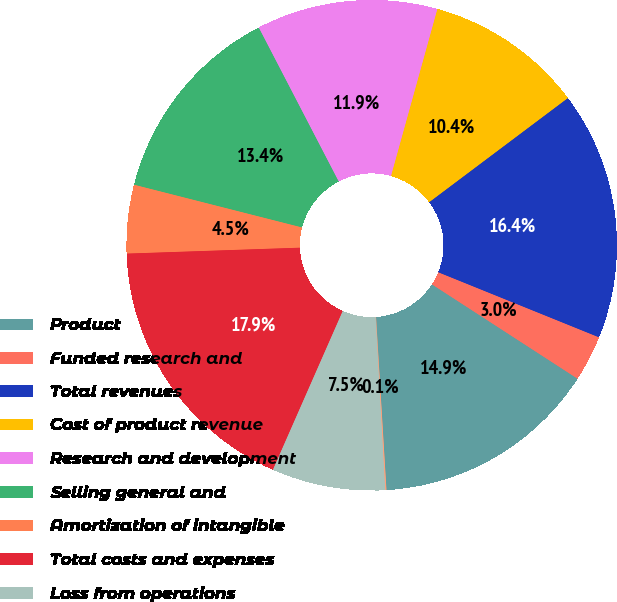<chart> <loc_0><loc_0><loc_500><loc_500><pie_chart><fcel>Product<fcel>Funded research and<fcel>Total revenues<fcel>Cost of product revenue<fcel>Research and development<fcel>Selling general and<fcel>Amortization of intangible<fcel>Total costs and expenses<fcel>Loss from operations<fcel>Gain on sale of WorldHeart<nl><fcel>14.89%<fcel>3.03%<fcel>16.37%<fcel>10.44%<fcel>11.93%<fcel>13.41%<fcel>4.51%<fcel>17.86%<fcel>7.48%<fcel>0.07%<nl></chart> 